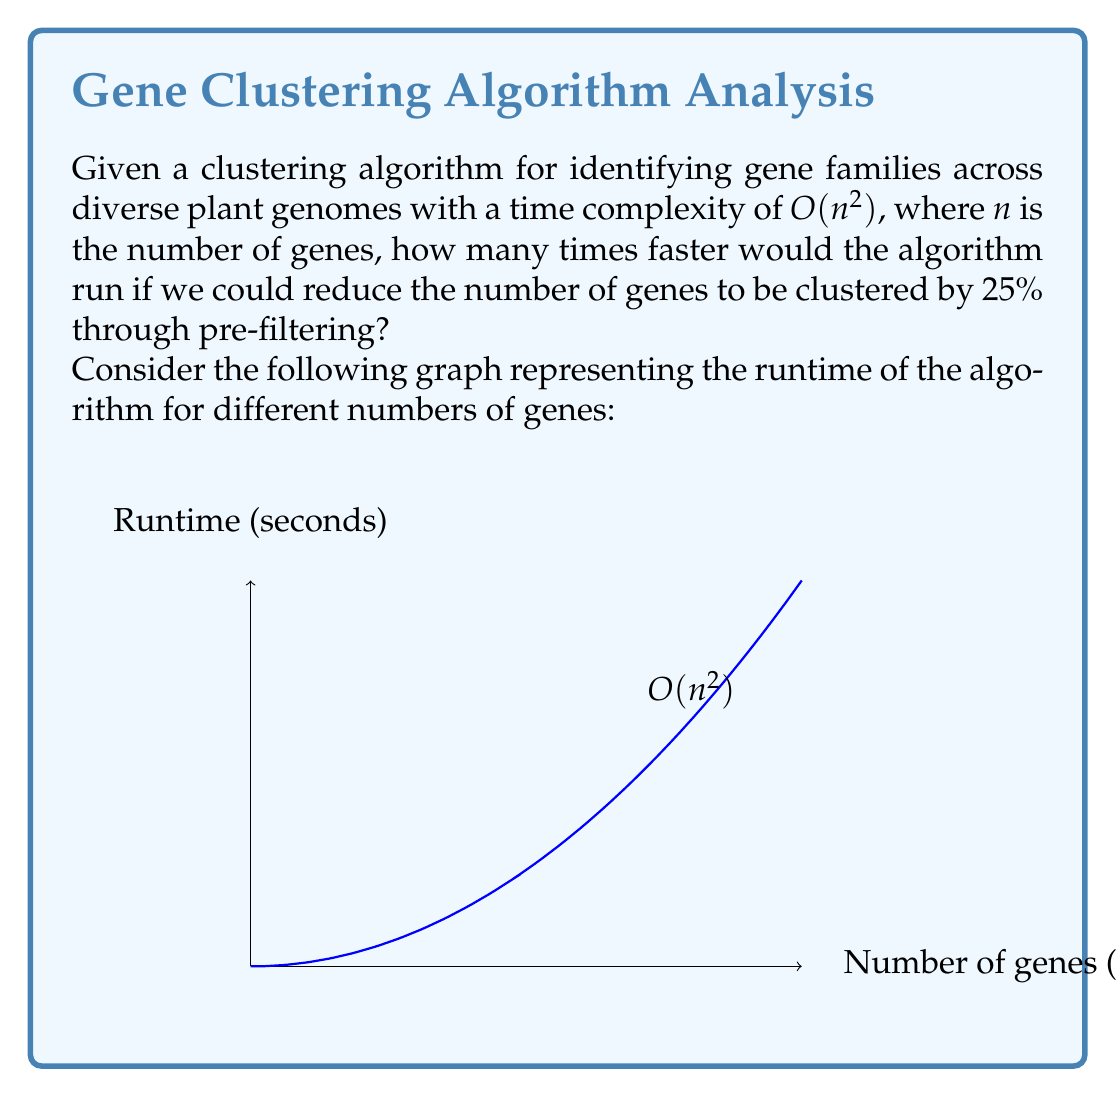Can you solve this math problem? To solve this problem, we need to follow these steps:

1) The time complexity of the algorithm is $O(n^2)$, which means the runtime is proportional to the square of the number of genes.

2) Let's consider the original runtime as $T_1 = k * n^2$, where $k$ is some constant factor.

3) If we reduce the number of genes by 25%, the new number of genes will be $0.75n$.

4) The new runtime will be $T_2 = k * (0.75n)^2$.

5) To find how many times faster the algorithm will run, we need to calculate the ratio $T_1 / T_2$:

   $$\frac{T_1}{T_2} = \frac{k * n^2}{k * (0.75n)^2}$$

6) The $k$ and $n$ cancel out:

   $$\frac{T_1}{T_2} = \frac{1}{(0.75)^2} = \frac{1}{0.5625}$$

7) Simplify the fraction:

   $$\frac{T_1}{T_2} = \frac{100}{56.25} = 1.7777...$$

8) This means the algorithm will run approximately 1.7778 times faster.
Answer: 1.7778 times faster 